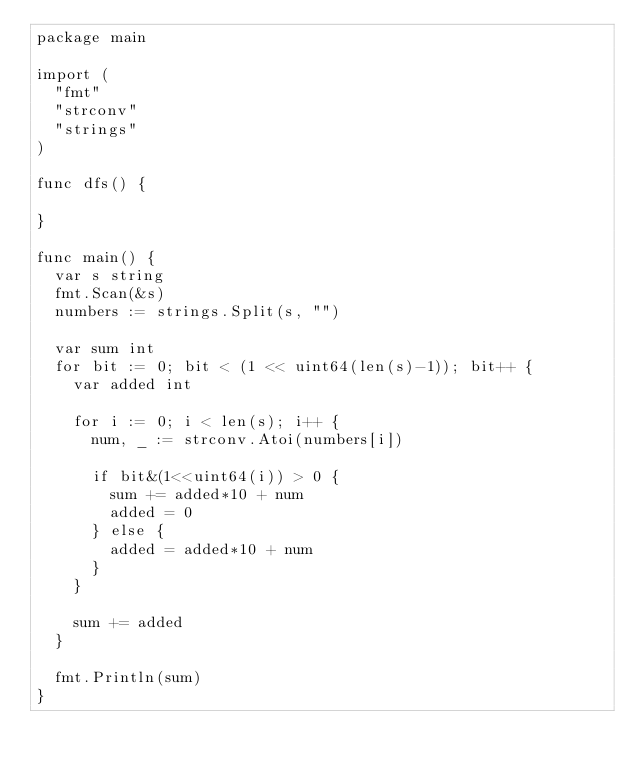Convert code to text. <code><loc_0><loc_0><loc_500><loc_500><_Go_>package main

import (
	"fmt"
	"strconv"
	"strings"
)

func dfs() {

}

func main() {
	var s string
	fmt.Scan(&s)
	numbers := strings.Split(s, "")

	var sum int
	for bit := 0; bit < (1 << uint64(len(s)-1)); bit++ {
		var added int

		for i := 0; i < len(s); i++ {
			num, _ := strconv.Atoi(numbers[i])

			if bit&(1<<uint64(i)) > 0 {
				sum += added*10 + num
				added = 0
			} else {
				added = added*10 + num
			}
		}

		sum += added
	}

	fmt.Println(sum)
}
</code> 